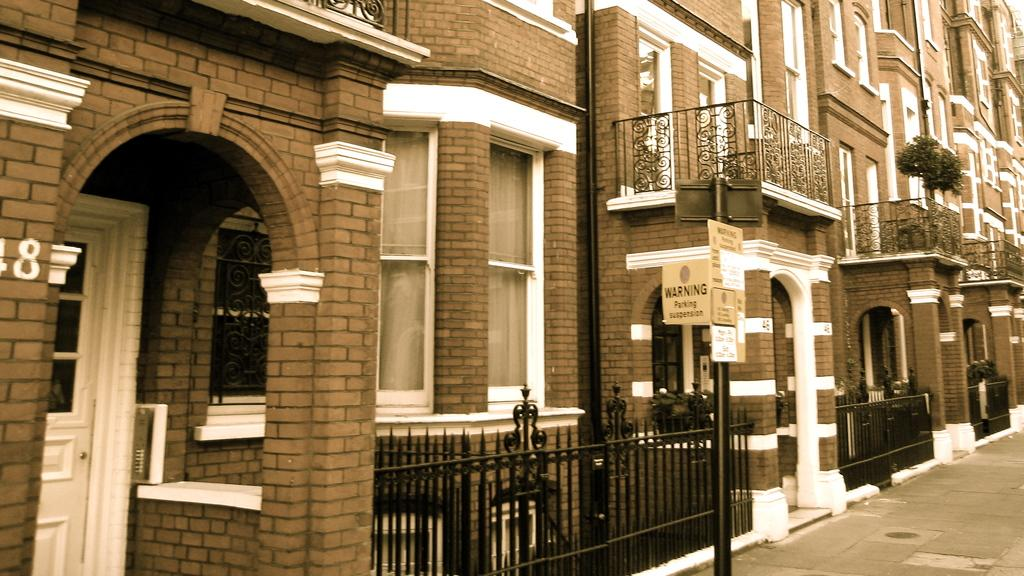What type of structures can be seen in the image? There are buildings in the image. What architectural features are present on the buildings? There are doors and windows in the image. What type of barrier can be seen in the image? There are fences in the image. What is the tall, vertical object in the image? There is a pole in the image, with boards attached to it. What type of vegetation is present in the image? House plants are present in the image. What type of pathway is visible in the image? There is a road in the image. What type of lettuce is growing on the pole in the image? There is no lettuce present in the image; it features a pole with boards attached to it. What sense is being stimulated by the house plants in the image? The provided facts do not specify which sense is being stimulated by the house plants; they are simply mentioned as being present in the image. 